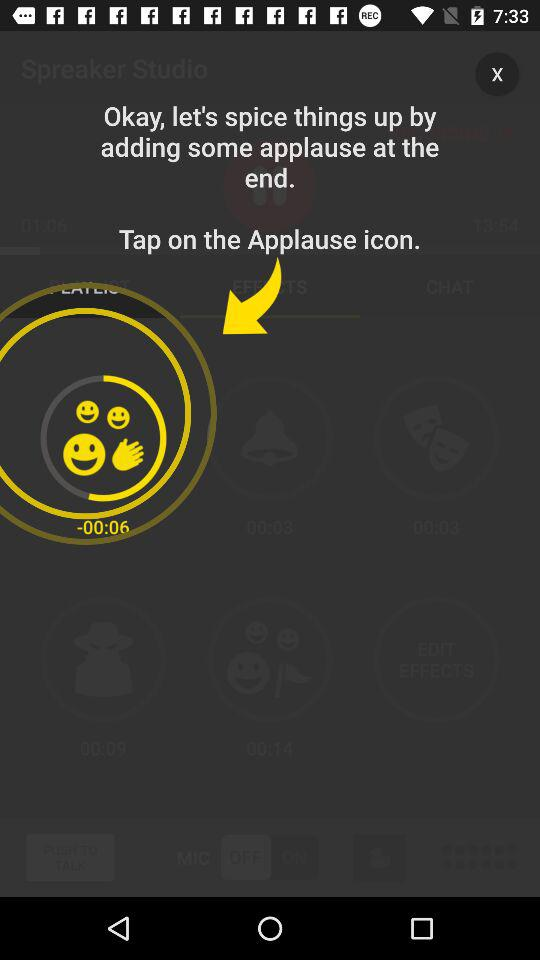How many items are in "CHAT"?
When the provided information is insufficient, respond with <no answer>. <no answer> 